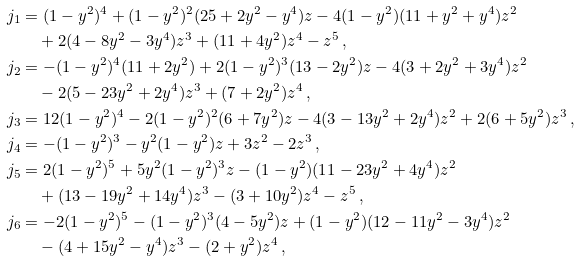<formula> <loc_0><loc_0><loc_500><loc_500>j _ { 1 } & = ( 1 - y ^ { 2 } ) ^ { 4 } + ( 1 - y ^ { 2 } ) ^ { 2 } ( 2 5 + 2 y ^ { 2 } - y ^ { 4 } ) z - 4 ( 1 - y ^ { 2 } ) ( 1 1 + y ^ { 2 } + y ^ { 4 } ) z ^ { 2 } \\ & \quad + 2 ( 4 - 8 y ^ { 2 } - 3 y ^ { 4 } ) z ^ { 3 } + ( 1 1 + 4 y ^ { 2 } ) z ^ { 4 } - z ^ { 5 } \, , \\ j _ { 2 } & = - ( 1 - y ^ { 2 } ) ^ { 4 } ( 1 1 + 2 y ^ { 2 } ) + 2 ( 1 - y ^ { 2 } ) ^ { 3 } ( 1 3 - 2 y ^ { 2 } ) z - 4 ( 3 + 2 y ^ { 2 } + 3 y ^ { 4 } ) z ^ { 2 } \\ & \quad - 2 ( 5 - 2 3 y ^ { 2 } + 2 y ^ { 4 } ) z ^ { 3 } + ( 7 + 2 y ^ { 2 } ) z ^ { 4 } \, , \\ j _ { 3 } & = 1 2 ( 1 - y ^ { 2 } ) ^ { 4 } - 2 ( 1 - y ^ { 2 } ) ^ { 2 } ( 6 + 7 y ^ { 2 } ) z - 4 ( 3 - 1 3 y ^ { 2 } + 2 y ^ { 4 } ) z ^ { 2 } + 2 ( 6 + 5 y ^ { 2 } ) z ^ { 3 } \, , \\ j _ { 4 } & = - ( 1 - y ^ { 2 } ) ^ { 3 } - y ^ { 2 } ( 1 - y ^ { 2 } ) z + 3 z ^ { 2 } - 2 z ^ { 3 } \, , \\ j _ { 5 } & = 2 ( 1 - y ^ { 2 } ) ^ { 5 } + 5 y ^ { 2 } ( 1 - y ^ { 2 } ) ^ { 3 } z - ( 1 - y ^ { 2 } ) ( 1 1 - 2 3 y ^ { 2 } + 4 y ^ { 4 } ) z ^ { 2 } \\ & \quad + ( 1 3 - 1 9 y ^ { 2 } + 1 4 y ^ { 4 } ) z ^ { 3 } - ( 3 + 1 0 y ^ { 2 } ) z ^ { 4 } - z ^ { 5 } \, , \\ j _ { 6 } & = - 2 ( 1 - y ^ { 2 } ) ^ { 5 } - ( 1 - y ^ { 2 } ) ^ { 3 } ( 4 - 5 y ^ { 2 } ) z + ( 1 - y ^ { 2 } ) ( 1 2 - 1 1 y ^ { 2 } - 3 y ^ { 4 } ) z ^ { 2 } \\ & \quad - ( 4 + 1 5 y ^ { 2 } - y ^ { 4 } ) z ^ { 3 } - ( 2 + y ^ { 2 } ) z ^ { 4 } \, ,</formula> 